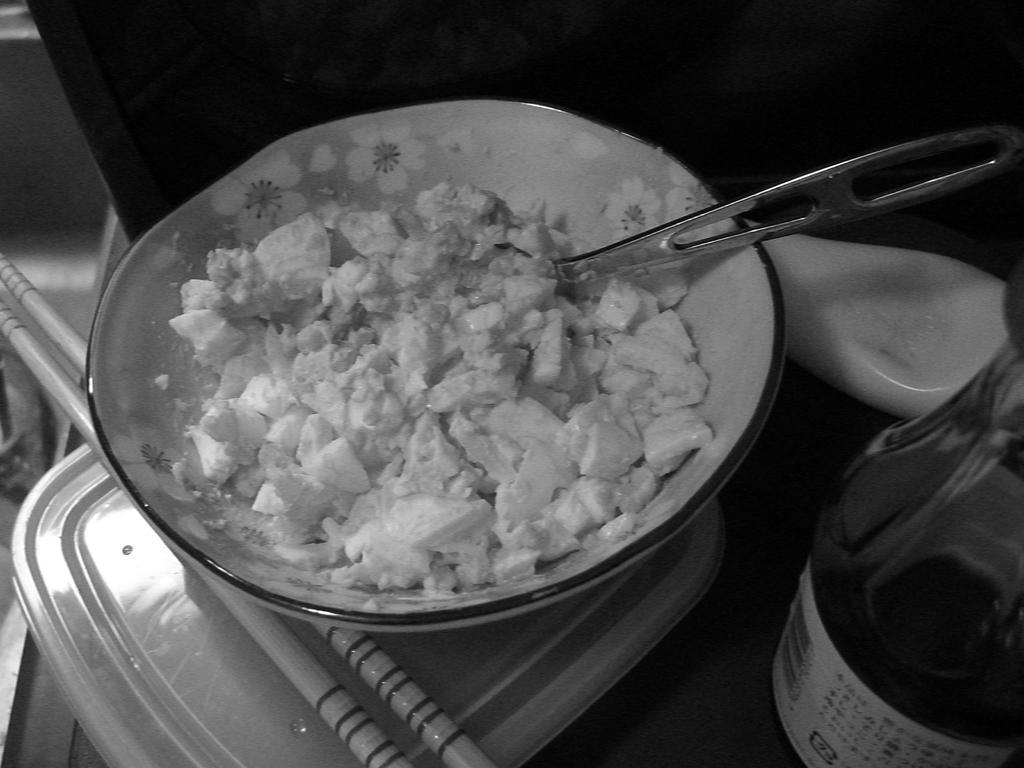Could you give a brief overview of what you see in this image? In this image we can see there is a table. On the table there is a bowl and in that there is some food item. And beside that there is a bottle, Spoon and few objects. 